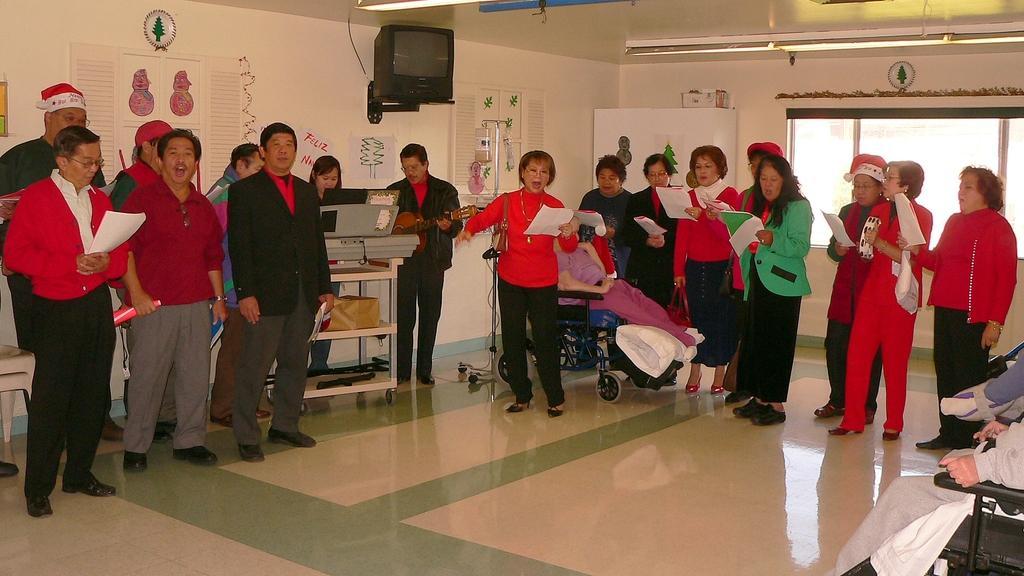Please provide a concise description of this image. In this image I can see some people are inside of the roam, some people are sitting on the chairs and there are holding papers and talking around I can see few objects, television, tables, windows to the wall and lights to the roof. 